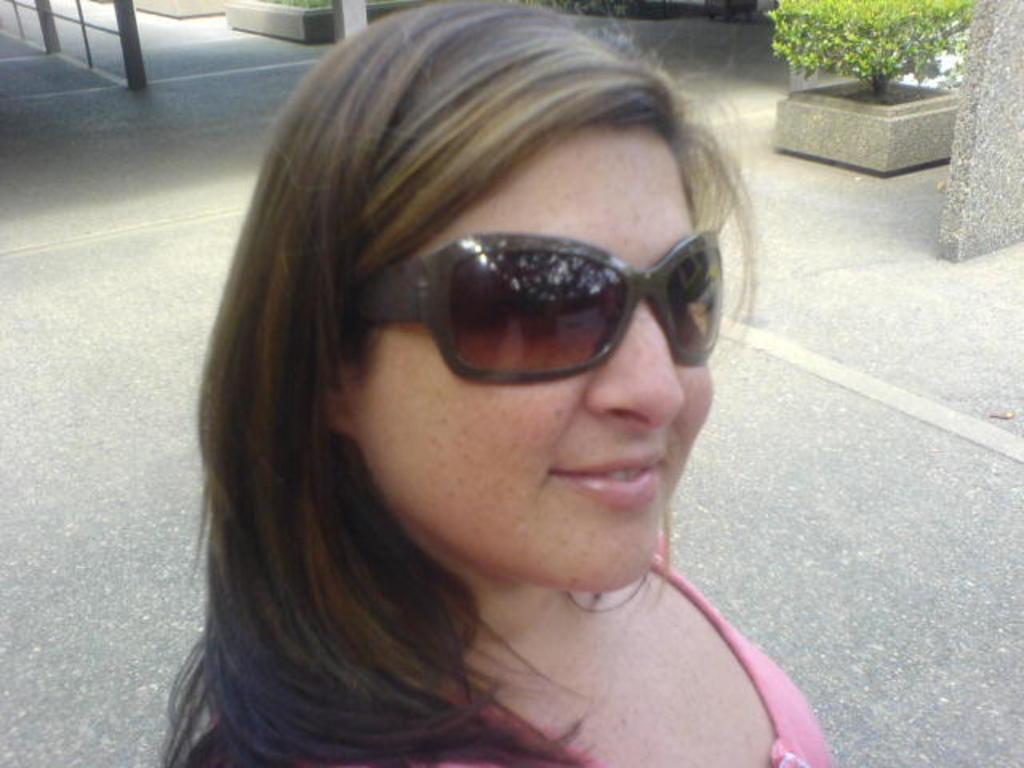Describe this image in one or two sentences. In this image woman is standing at front. At the background there are flower pots. 